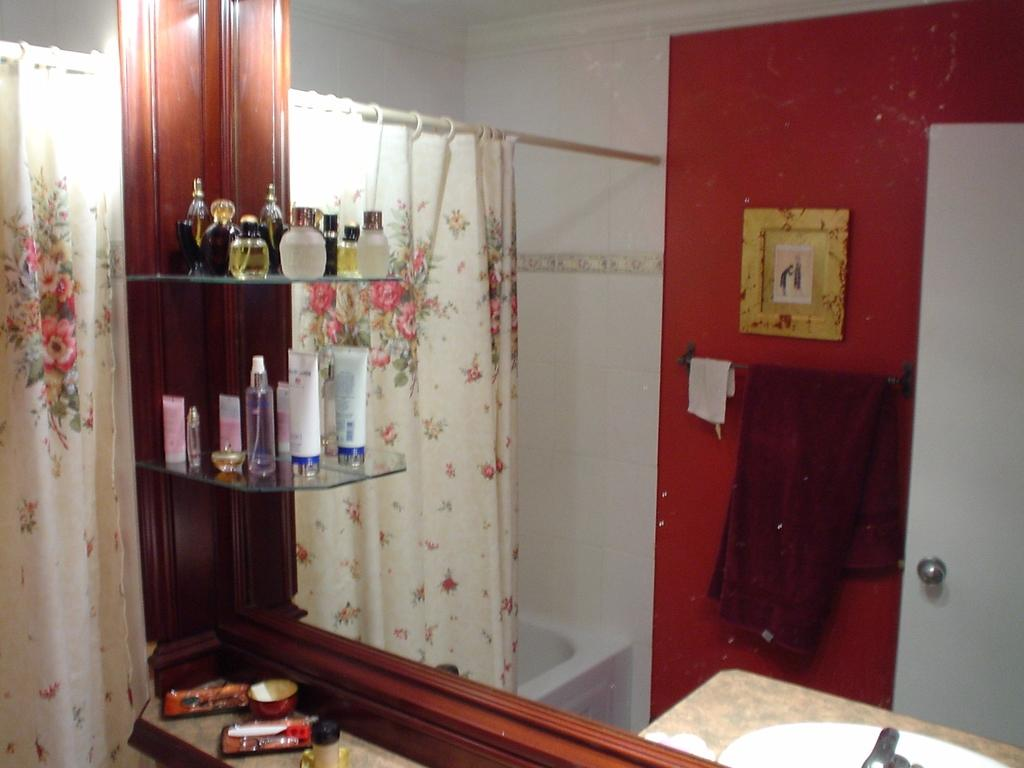What is one of the main fixtures in the image? There is a mirror in the image. What other fixture is present in the image? There is a wash basin in the image. What is the largest fixture in the image? There is a bathtub in the image. What type of window treatment is present in the image? There is a curtain in the image. What is the curtain attached to? There is a rod in the image. What type of room is the image taken in? The image is taken in a room. What type of knife is being used to cut the rainstorm in the image? There is no knife or rainstorm present in the image. 